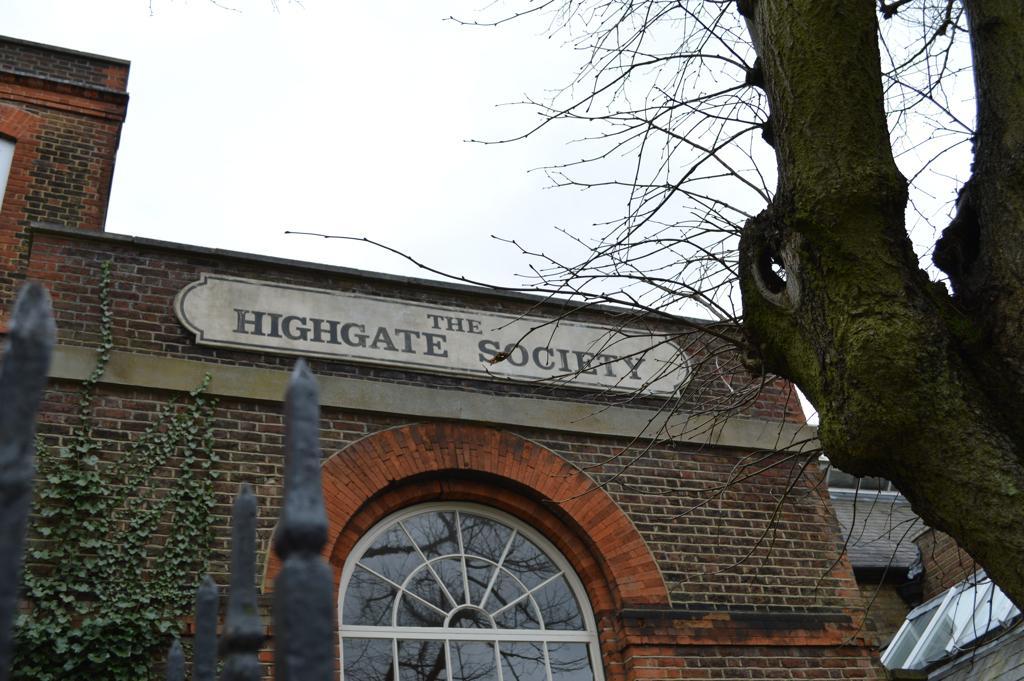In one or two sentences, can you explain what this image depicts? In this image, we can see walls, glass objects, plants, tree and rods. In the middle of the image, we can see a board with text on the wall. At the top of the image, we can see the sky. 